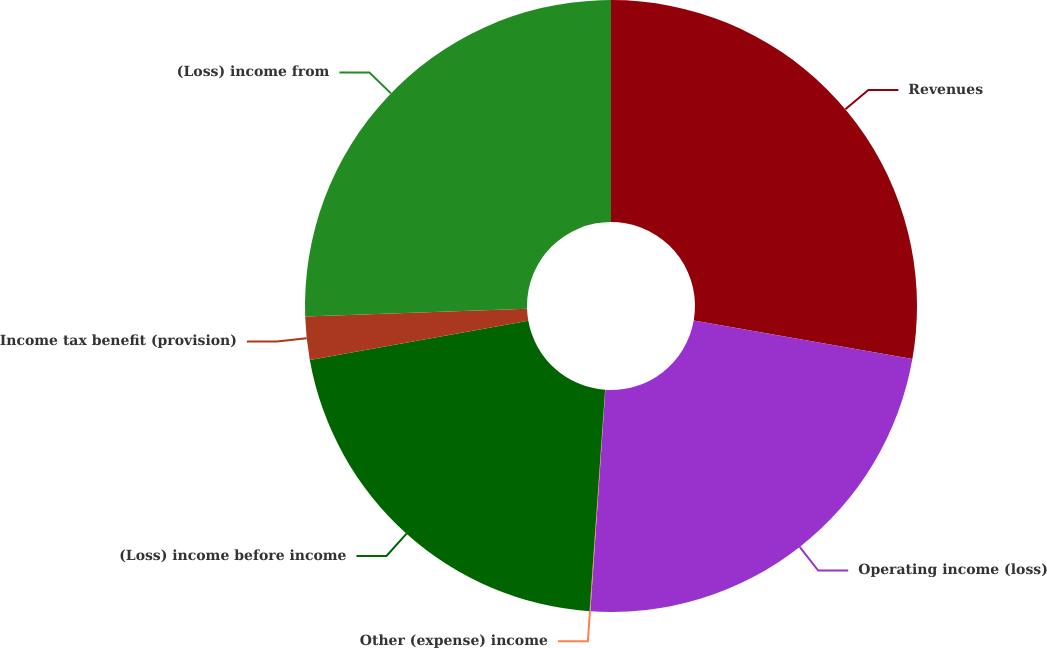<chart> <loc_0><loc_0><loc_500><loc_500><pie_chart><fcel>Revenues<fcel>Operating income (loss)<fcel>Other (expense) income<fcel>(Loss) income before income<fcel>Income tax benefit (provision)<fcel>(Loss) income from<nl><fcel>27.77%<fcel>23.3%<fcel>0.04%<fcel>21.06%<fcel>2.28%<fcel>25.54%<nl></chart> 